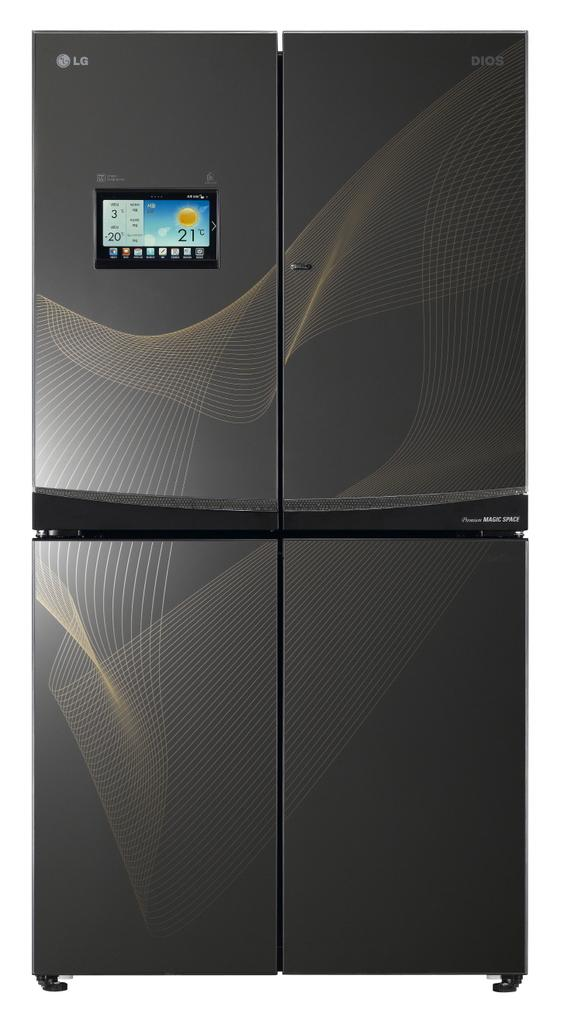<image>
Give a short and clear explanation of the subsequent image. The black appliance here is from the company LG 